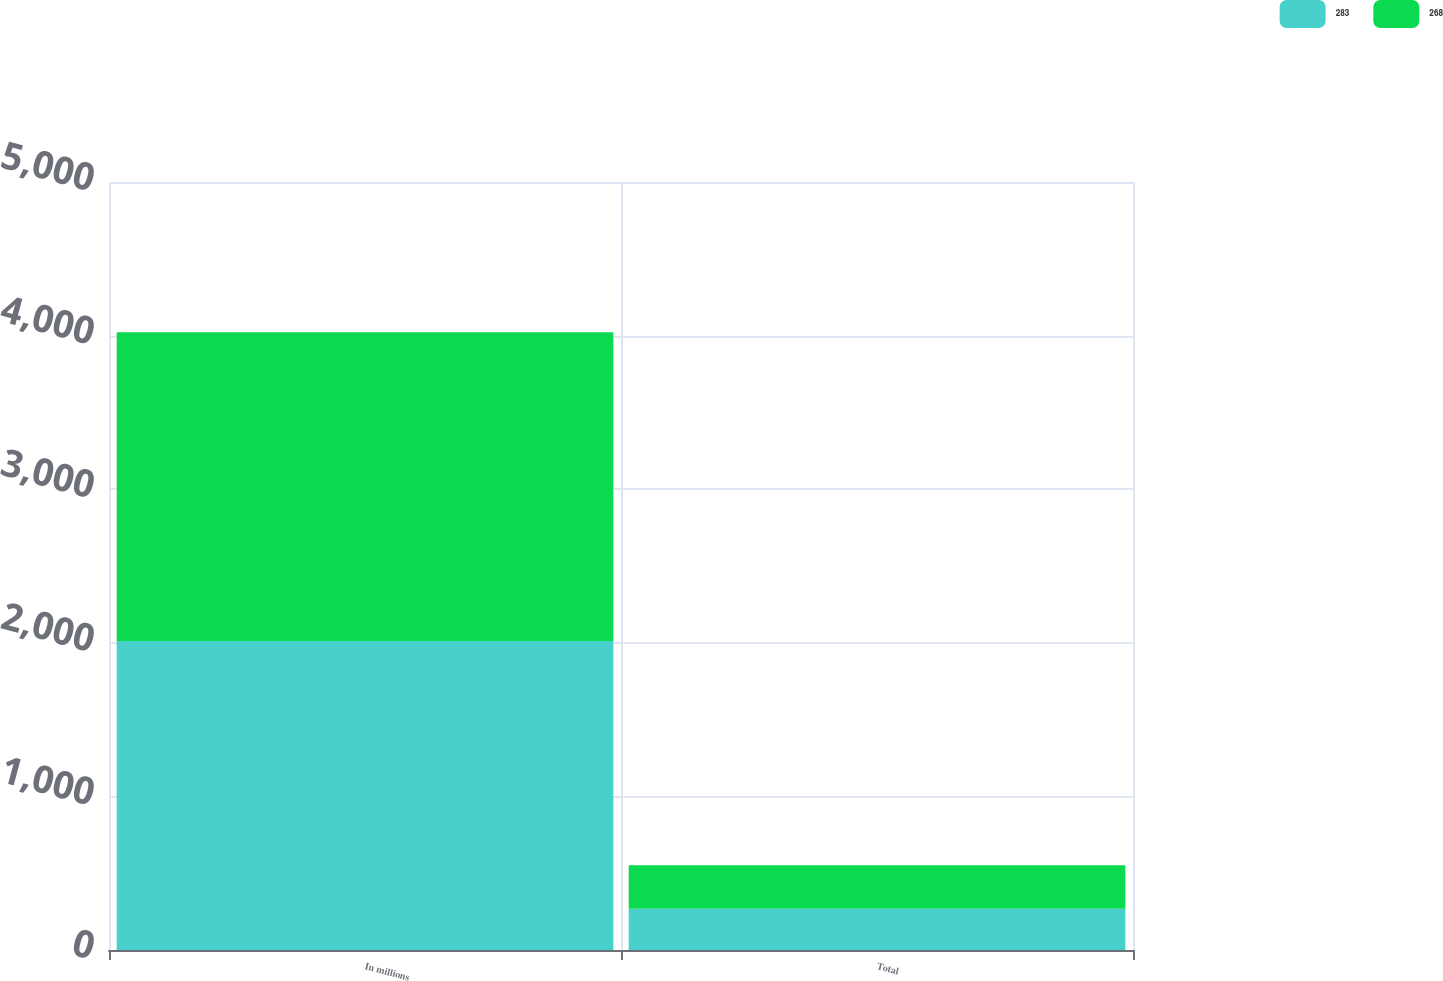Convert chart. <chart><loc_0><loc_0><loc_500><loc_500><stacked_bar_chart><ecel><fcel>In millions<fcel>Total<nl><fcel>283<fcel>2011<fcel>268<nl><fcel>268<fcel>2010<fcel>283<nl></chart> 